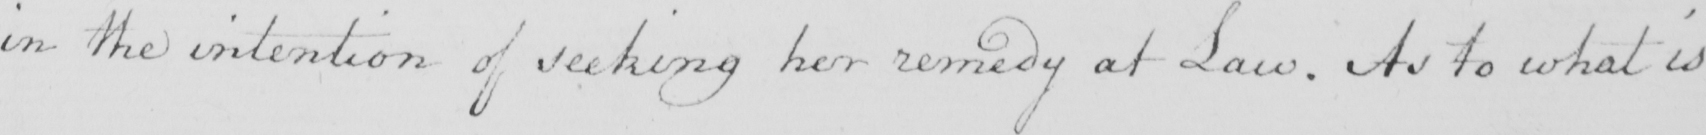Can you read and transcribe this handwriting? in the intention of seeking her remedy at Law . As to what is 